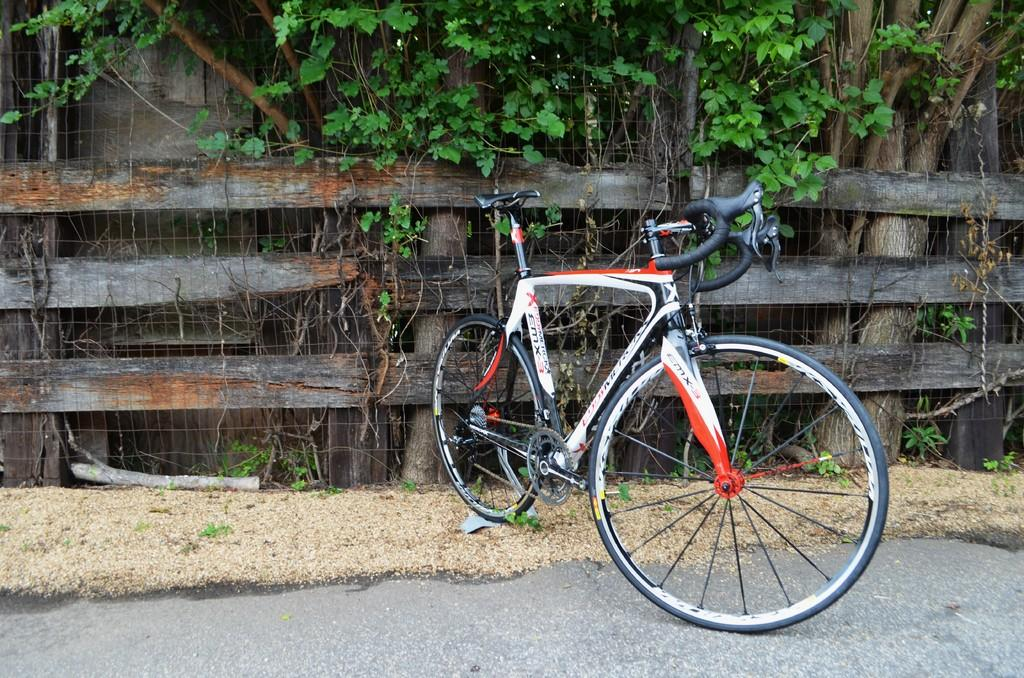What is parked on the road in the image? There is a bicycle parked on the road in the image. Where is the bicycle located in relation to the wooden fencing? The bicycle is near a wooden fencing in the image. What can be seen beyond the wooden fencing? There are trees outside the wooden fencing in the image. What type of structure is visible in the image? There is a wall visible in the image. What committee is responsible for the prose displayed on the wall in the image? There is no prose or committee mentioned in the image; it only features a bicycle, wooden fencing, trees, and a wall. 